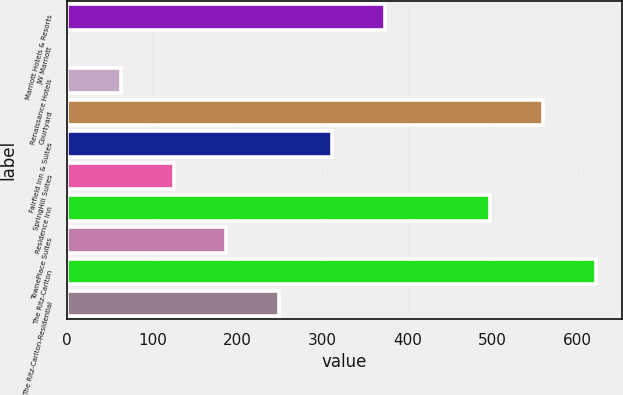Convert chart. <chart><loc_0><loc_0><loc_500><loc_500><bar_chart><fcel>Marriott Hotels & Resorts<fcel>JW Marriott<fcel>Renaissance Hotels<fcel>Courtyard<fcel>Fairfield Inn & Suites<fcel>SpringHill Suites<fcel>Residence Inn<fcel>TownePlace Suites<fcel>The Ritz-Carlton<fcel>The Ritz-Carlton-Residential<nl><fcel>373<fcel>1<fcel>63<fcel>559<fcel>311<fcel>125<fcel>497<fcel>187<fcel>621<fcel>249<nl></chart> 